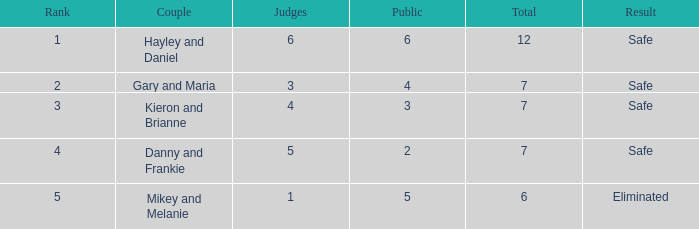How many people were there when the vote percentage stood at 22.9%? 1.0. 